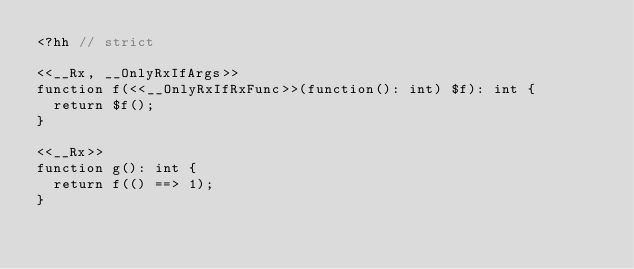<code> <loc_0><loc_0><loc_500><loc_500><_PHP_><?hh // strict

<<__Rx, __OnlyRxIfArgs>>
function f(<<__OnlyRxIfRxFunc>>(function(): int) $f): int {
  return $f();
}

<<__Rx>>
function g(): int {
  return f(() ==> 1);
}
</code> 